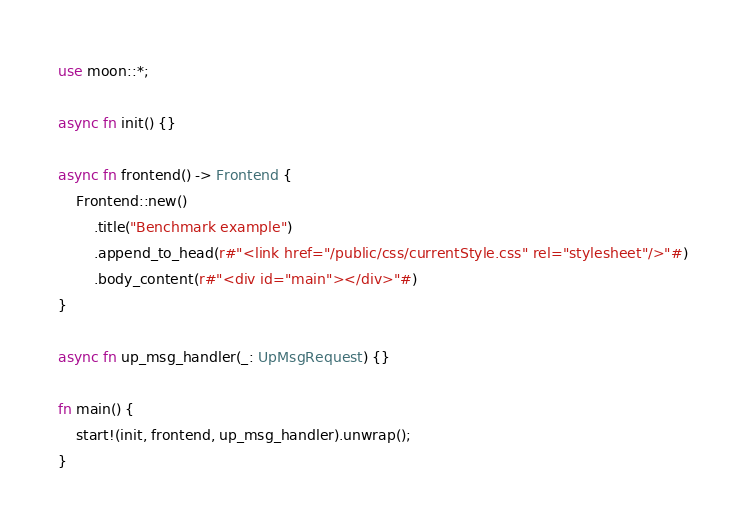Convert code to text. <code><loc_0><loc_0><loc_500><loc_500><_Rust_>use moon::*;

async fn init() {}

async fn frontend() -> Frontend {
    Frontend::new()
        .title("Benchmark example")
        .append_to_head(r#"<link href="/public/css/currentStyle.css" rel="stylesheet"/>"#)
        .body_content(r#"<div id="main"></div>"#)
}

async fn up_msg_handler(_: UpMsgRequest) {}

fn main() {
    start!(init, frontend, up_msg_handler).unwrap();
}
</code> 